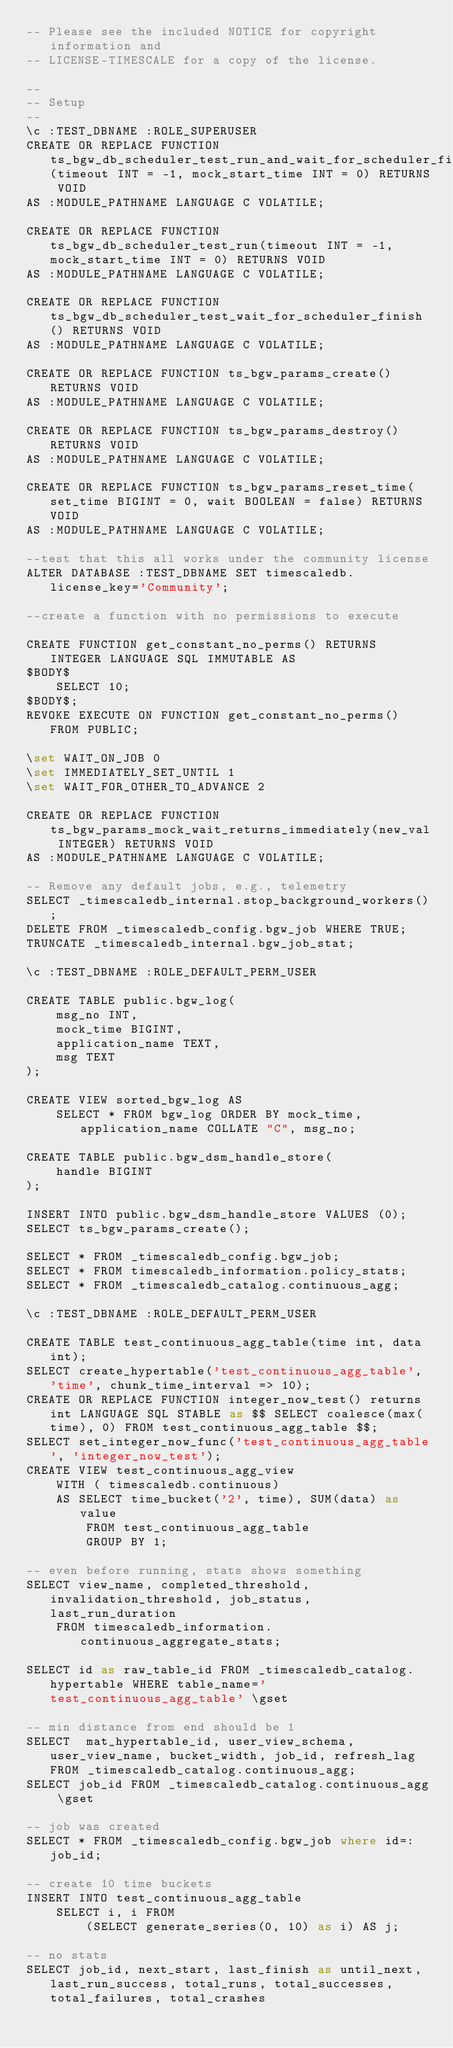Convert code to text. <code><loc_0><loc_0><loc_500><loc_500><_SQL_>-- Please see the included NOTICE for copyright information and
-- LICENSE-TIMESCALE for a copy of the license.

--
-- Setup
--
\c :TEST_DBNAME :ROLE_SUPERUSER
CREATE OR REPLACE FUNCTION ts_bgw_db_scheduler_test_run_and_wait_for_scheduler_finish(timeout INT = -1, mock_start_time INT = 0) RETURNS VOID
AS :MODULE_PATHNAME LANGUAGE C VOLATILE;

CREATE OR REPLACE FUNCTION ts_bgw_db_scheduler_test_run(timeout INT = -1, mock_start_time INT = 0) RETURNS VOID
AS :MODULE_PATHNAME LANGUAGE C VOLATILE;

CREATE OR REPLACE FUNCTION ts_bgw_db_scheduler_test_wait_for_scheduler_finish() RETURNS VOID
AS :MODULE_PATHNAME LANGUAGE C VOLATILE;

CREATE OR REPLACE FUNCTION ts_bgw_params_create() RETURNS VOID
AS :MODULE_PATHNAME LANGUAGE C VOLATILE;

CREATE OR REPLACE FUNCTION ts_bgw_params_destroy() RETURNS VOID
AS :MODULE_PATHNAME LANGUAGE C VOLATILE;

CREATE OR REPLACE FUNCTION ts_bgw_params_reset_time(set_time BIGINT = 0, wait BOOLEAN = false) RETURNS VOID
AS :MODULE_PATHNAME LANGUAGE C VOLATILE;

--test that this all works under the community license
ALTER DATABASE :TEST_DBNAME SET timescaledb.license_key='Community';

--create a function with no permissions to execute

CREATE FUNCTION get_constant_no_perms() RETURNS INTEGER LANGUAGE SQL IMMUTABLE AS
$BODY$
    SELECT 10;
$BODY$;
REVOKE EXECUTE ON FUNCTION get_constant_no_perms() FROM PUBLIC;

\set WAIT_ON_JOB 0
\set IMMEDIATELY_SET_UNTIL 1
\set WAIT_FOR_OTHER_TO_ADVANCE 2

CREATE OR REPLACE FUNCTION ts_bgw_params_mock_wait_returns_immediately(new_val INTEGER) RETURNS VOID
AS :MODULE_PATHNAME LANGUAGE C VOLATILE;

-- Remove any default jobs, e.g., telemetry
SELECT _timescaledb_internal.stop_background_workers();
DELETE FROM _timescaledb_config.bgw_job WHERE TRUE;
TRUNCATE _timescaledb_internal.bgw_job_stat;

\c :TEST_DBNAME :ROLE_DEFAULT_PERM_USER

CREATE TABLE public.bgw_log(
    msg_no INT,
    mock_time BIGINT,
    application_name TEXT,
    msg TEXT
);

CREATE VIEW sorted_bgw_log AS
    SELECT * FROM bgw_log ORDER BY mock_time, application_name COLLATE "C", msg_no;

CREATE TABLE public.bgw_dsm_handle_store(
    handle BIGINT
);

INSERT INTO public.bgw_dsm_handle_store VALUES (0);
SELECT ts_bgw_params_create();

SELECT * FROM _timescaledb_config.bgw_job;
SELECT * FROM timescaledb_information.policy_stats;
SELECT * FROM _timescaledb_catalog.continuous_agg;

\c :TEST_DBNAME :ROLE_DEFAULT_PERM_USER

CREATE TABLE test_continuous_agg_table(time int, data int);
SELECT create_hypertable('test_continuous_agg_table', 'time', chunk_time_interval => 10);
CREATE OR REPLACE FUNCTION integer_now_test() returns int LANGUAGE SQL STABLE as $$ SELECT coalesce(max(time), 0) FROM test_continuous_agg_table $$;
SELECT set_integer_now_func('test_continuous_agg_table', 'integer_now_test');
CREATE VIEW test_continuous_agg_view
    WITH ( timescaledb.continuous)
    AS SELECT time_bucket('2', time), SUM(data) as value
        FROM test_continuous_agg_table
        GROUP BY 1;

-- even before running, stats shows something
SELECT view_name, completed_threshold, invalidation_threshold, job_status, last_run_duration
    FROM timescaledb_information.continuous_aggregate_stats;

SELECT id as raw_table_id FROM _timescaledb_catalog.hypertable WHERE table_name='test_continuous_agg_table' \gset

-- min distance from end should be 1
SELECT  mat_hypertable_id, user_view_schema, user_view_name, bucket_width, job_id, refresh_lag FROM _timescaledb_catalog.continuous_agg;
SELECT job_id FROM _timescaledb_catalog.continuous_agg \gset

-- job was created
SELECT * FROM _timescaledb_config.bgw_job where id=:job_id;

-- create 10 time buckets
INSERT INTO test_continuous_agg_table
    SELECT i, i FROM
        (SELECT generate_series(0, 10) as i) AS j;

-- no stats
SELECT job_id, next_start, last_finish as until_next, last_run_success, total_runs, total_successes, total_failures, total_crashes</code> 